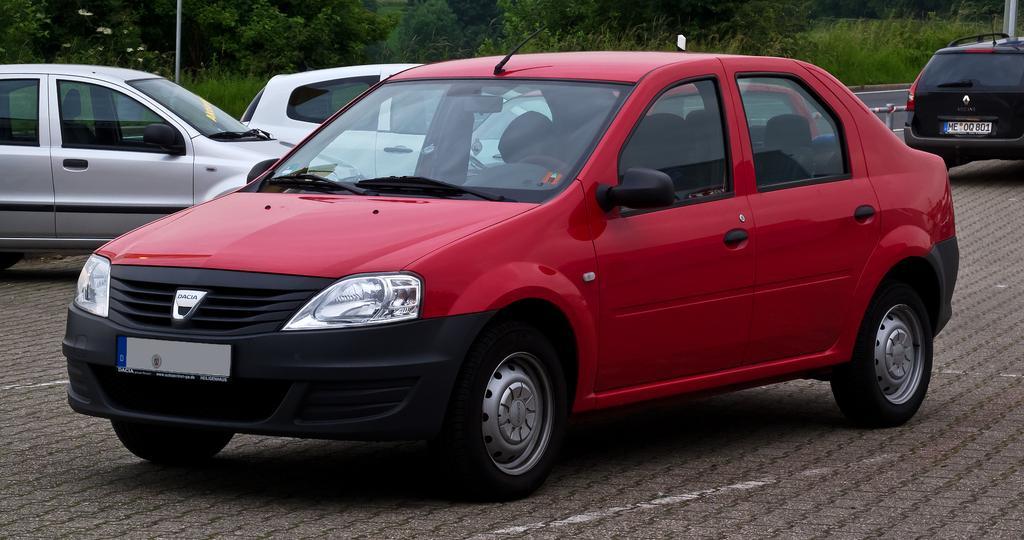How would you summarize this image in a sentence or two? In this image in the center there are some cars, and at the bottom there is a road and in the background there are some trees and poles. 